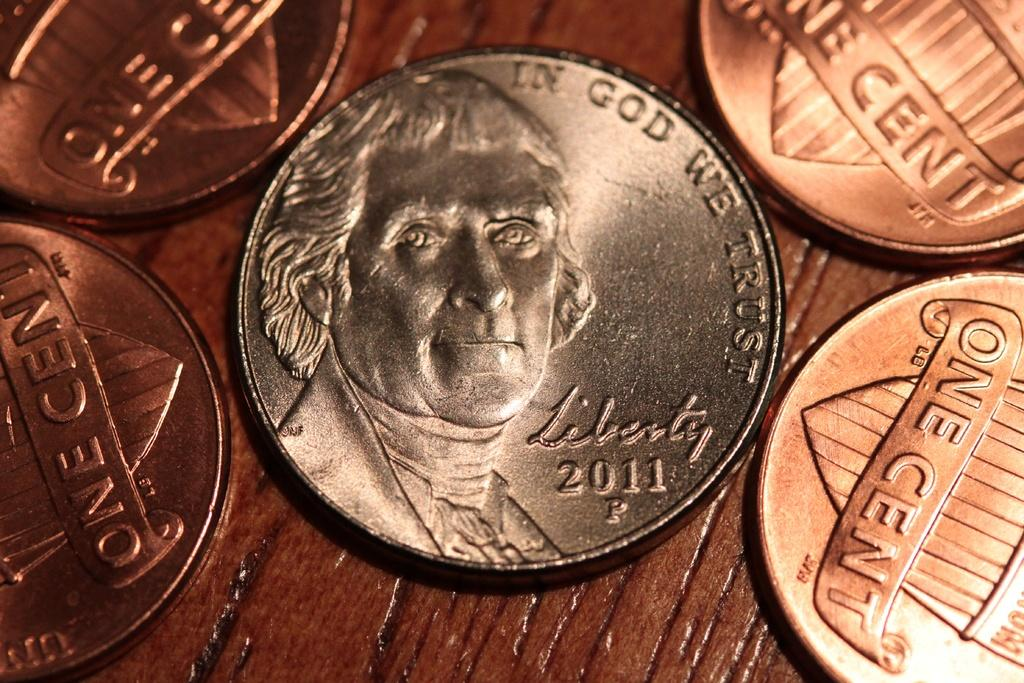<image>
Relay a brief, clear account of the picture shown. FOUR SHINY NEW PENNIES AND A 2011 NICKEL 